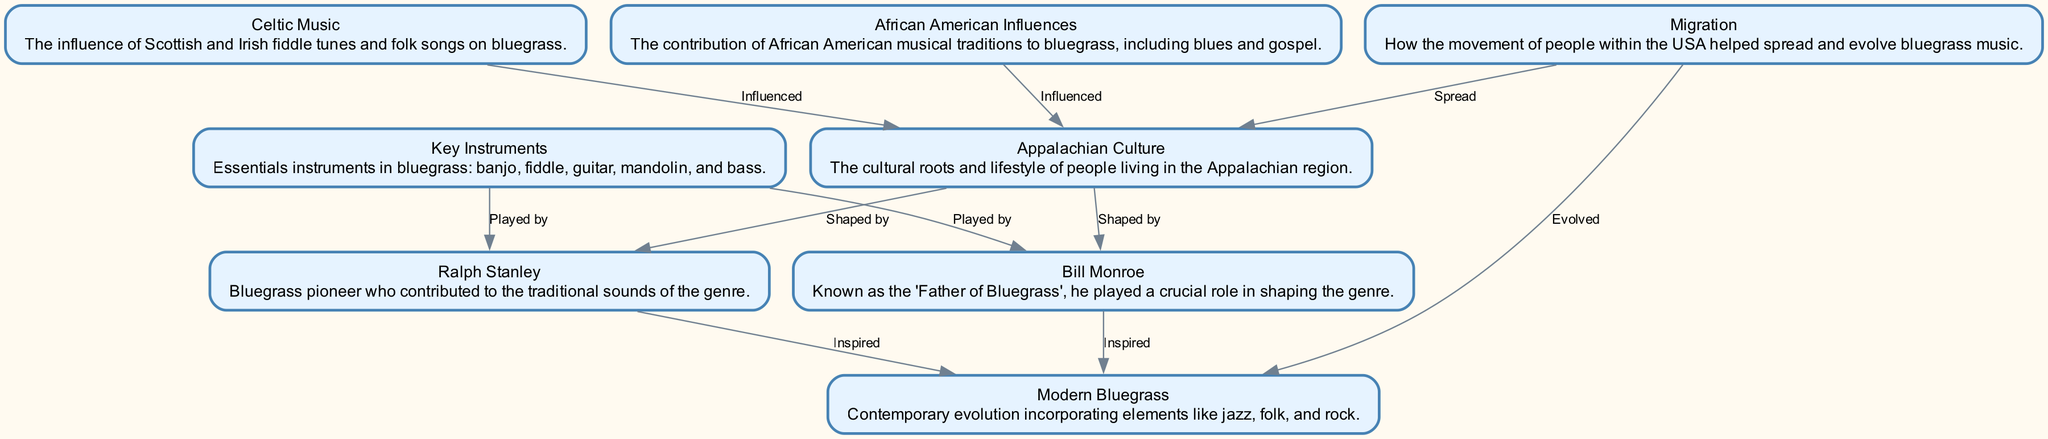What is the first node in the diagram? The first node in the diagram is "Appalachian Culture," which represents the cultural roots and lifestyle of people living in the Appalachian region.
Answer: Appalachian Culture How many nodes are there in total? The diagram includes 8 nodes, each representing a different aspect or influence related to bluegrass music.
Answer: 8 Which node is influenced by both African American and Celtic Music? "Appalachian Culture" is influenced by both African American influences and Celtic music, indicating the diverse roots of bluegrass.
Answer: Appalachian Culture What role did Bill Monroe play in the evolution of bluegrass? Bill Monroe is described as the "Father of Bluegrass" and is influenced and inspired modern bluegrass music, showing his crucial role in shaping the genre.
Answer: Father of Bluegrass Which two nodes are both shaped by Appalachian Culture? Both "Bill Monroe" and "Ralph Stanley" are shaped by Appalachian Culture, highlighting how the regional lifestyle influenced their music.
Answer: Bill Monroe and Ralph Stanley How does Migration affect both Appalachian Culture and Modern Bluegrass? The Migration node shows that it spread Appalachian Culture and evolved Modern Bluegrass, demonstrating how people's movement influenced these aspects of bluegrass music.
Answer: Spread and Evolved What are the key instruments highlighted in the diagram? The key instruments in bluegrass music mentioned in the diagram are banjo, fiddle, guitar, mandolin, and bass.
Answer: Banjo, fiddle, guitar, mandolin, bass Which nodes inspire Modern Bluegrass? Both "Bill Monroe" and "Ralph Stanley" are listed as inspirations for Modern Bluegrass, indicating their lasting impact on the genre's evolution.
Answer: Bill Monroe and Ralph Stanley 